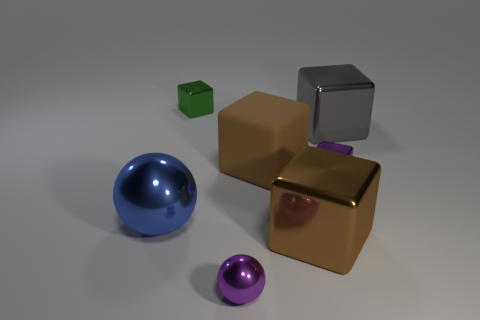There is a tiny cube that is the same color as the tiny metal ball; what is it made of?
Make the answer very short. Metal. Is the color of the tiny shiny block behind the small purple metallic block the same as the tiny sphere?
Make the answer very short. No. How many other objects are there of the same color as the large rubber block?
Your answer should be very brief. 1. There is a tiny metallic object that is behind the big rubber cube; is it the same shape as the gray shiny thing?
Ensure brevity in your answer.  Yes. What is the color of the block that is in front of the big thing on the left side of the big rubber cube?
Make the answer very short. Brown. Is the number of big shiny balls less than the number of cubes?
Offer a terse response. Yes. Is there a blue object made of the same material as the small purple sphere?
Keep it short and to the point. Yes. There is a big blue thing; is its shape the same as the big brown thing behind the brown metal object?
Your answer should be compact. No. There is a small green block; are there any purple blocks left of it?
Offer a terse response. No. How many purple things have the same shape as the brown metal thing?
Offer a very short reply. 1. 